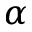Convert formula to latex. <formula><loc_0><loc_0><loc_500><loc_500>\alpha</formula> 